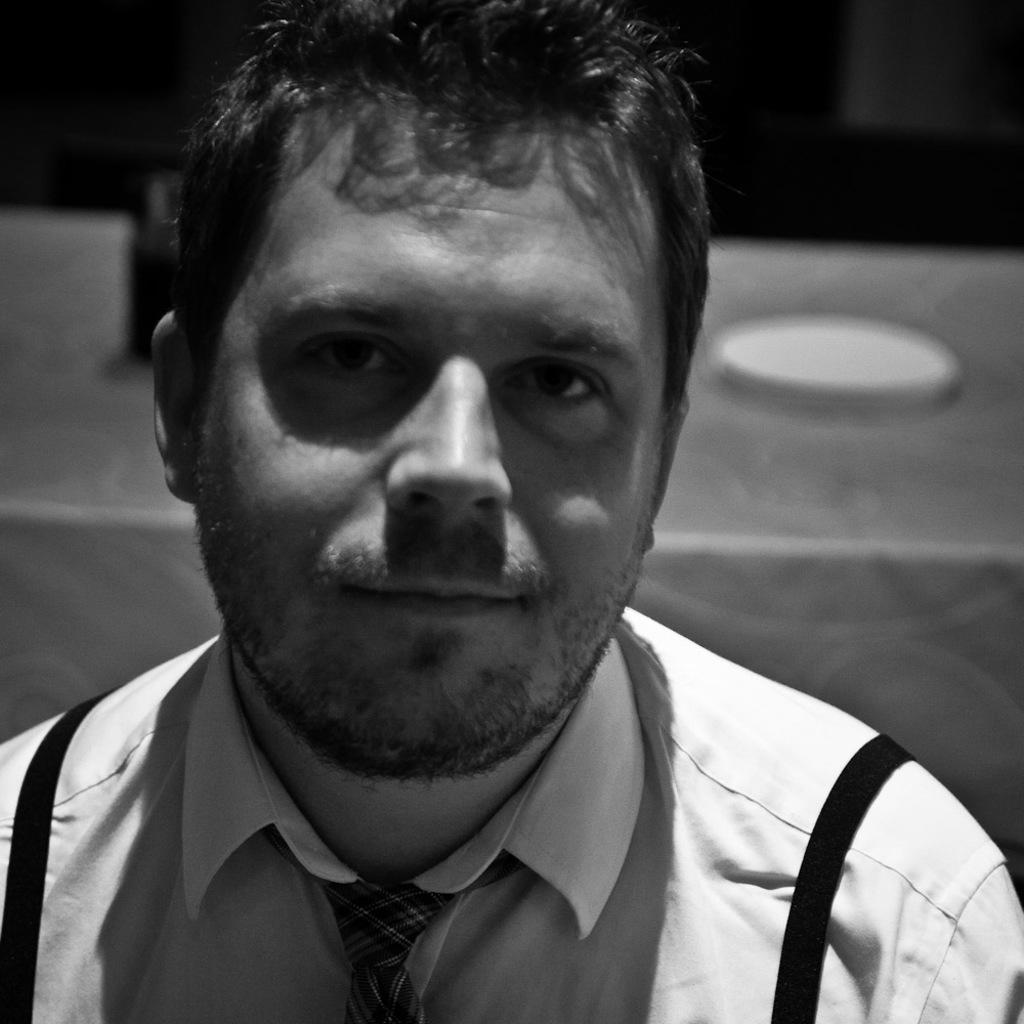Who is present in the image? There is a man in the image. What is the man wearing around his neck? The man is wearing a tie. What expression does the man have on his face? The man is smiling. What can be observed about the background of the image? The background of the image is dark. What type of quartz can be seen on the tray in the image? There is no quartz or tray present in the image; it only features a man with a tie and a dark background. 